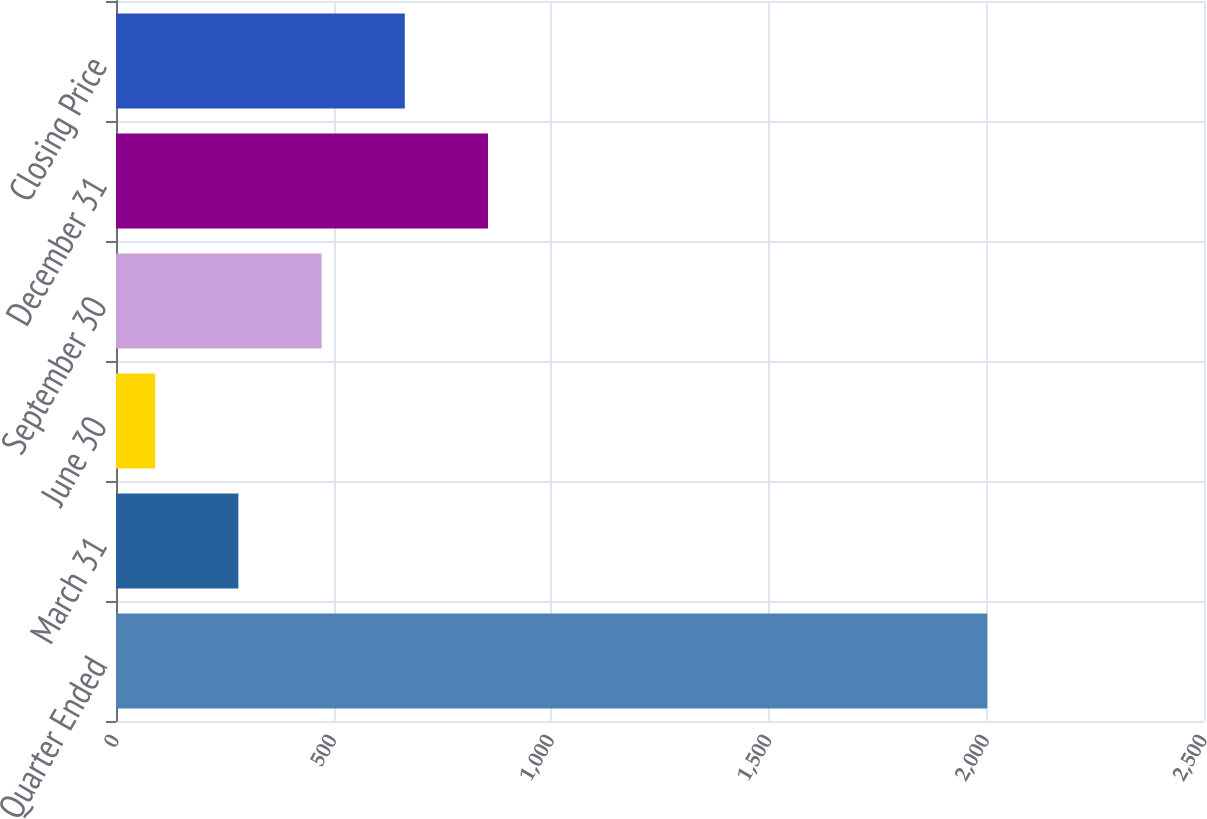Convert chart. <chart><loc_0><loc_0><loc_500><loc_500><bar_chart><fcel>Quarter Ended<fcel>March 31<fcel>June 30<fcel>September 30<fcel>December 31<fcel>Closing Price<nl><fcel>2002<fcel>281.2<fcel>90<fcel>472.4<fcel>854.8<fcel>663.6<nl></chart> 